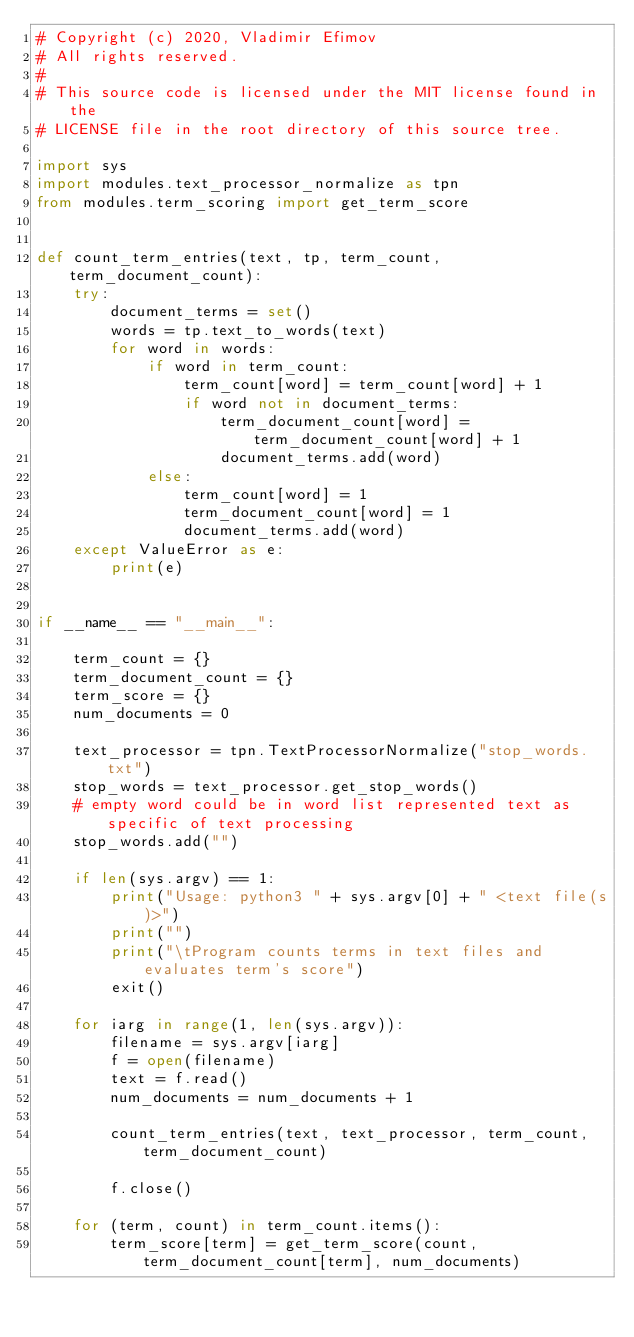<code> <loc_0><loc_0><loc_500><loc_500><_Python_># Copyright (c) 2020, Vladimir Efimov
# All rights reserved.
#
# This source code is licensed under the MIT license found in the
# LICENSE file in the root directory of this source tree.

import sys
import modules.text_processor_normalize as tpn
from modules.term_scoring import get_term_score


def count_term_entries(text, tp, term_count, term_document_count):
    try:
        document_terms = set()
        words = tp.text_to_words(text)
        for word in words:
            if word in term_count:
                term_count[word] = term_count[word] + 1
                if word not in document_terms:
                    term_document_count[word] = term_document_count[word] + 1
                    document_terms.add(word)
            else:
                term_count[word] = 1
                term_document_count[word] = 1
                document_terms.add(word)
    except ValueError as e:
        print(e)


if __name__ == "__main__":

    term_count = {}
    term_document_count = {}
    term_score = {}
    num_documents = 0

    text_processor = tpn.TextProcessorNormalize("stop_words.txt")
    stop_words = text_processor.get_stop_words()
    # empty word could be in word list represented text as specific of text processing
    stop_words.add("")

    if len(sys.argv) == 1:
        print("Usage: python3 " + sys.argv[0] + " <text file(s)>")
        print("")
        print("\tProgram counts terms in text files and evaluates term's score")
        exit()

    for iarg in range(1, len(sys.argv)):
        filename = sys.argv[iarg]
        f = open(filename)
        text = f.read()
        num_documents = num_documents + 1

        count_term_entries(text, text_processor, term_count, term_document_count)

        f.close()

    for (term, count) in term_count.items():
        term_score[term] = get_term_score(count, term_document_count[term], num_documents)
</code> 